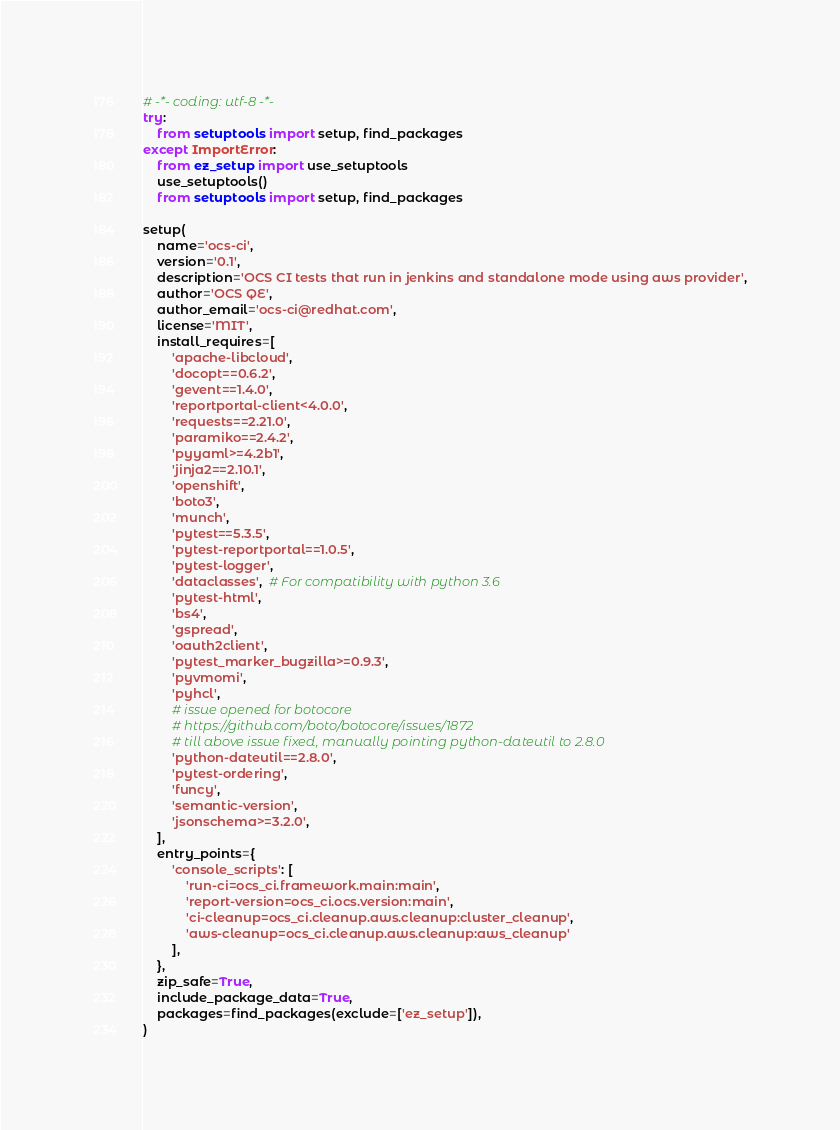Convert code to text. <code><loc_0><loc_0><loc_500><loc_500><_Python_># -*- coding: utf-8 -*-
try:
    from setuptools import setup, find_packages
except ImportError:
    from ez_setup import use_setuptools
    use_setuptools()
    from setuptools import setup, find_packages

setup(
    name='ocs-ci',
    version='0.1',
    description='OCS CI tests that run in jenkins and standalone mode using aws provider',
    author='OCS QE',
    author_email='ocs-ci@redhat.com',
    license='MIT',
    install_requires=[
        'apache-libcloud',
        'docopt==0.6.2',
        'gevent==1.4.0',
        'reportportal-client<4.0.0',
        'requests==2.21.0',
        'paramiko==2.4.2',
        'pyyaml>=4.2b1',
        'jinja2==2.10.1',
        'openshift',
        'boto3',
        'munch',
        'pytest==5.3.5',
        'pytest-reportportal==1.0.5',
        'pytest-logger',
        'dataclasses',  # For compatibility with python 3.6
        'pytest-html',
        'bs4',
        'gspread',
        'oauth2client',
        'pytest_marker_bugzilla>=0.9.3',
        'pyvmomi',
        'pyhcl',
        # issue opened for botocore
        # https://github.com/boto/botocore/issues/1872
        # till above issue fixed, manually pointing python-dateutil to 2.8.0
        'python-dateutil==2.8.0',
        'pytest-ordering',
        'funcy',
        'semantic-version',
        'jsonschema>=3.2.0',
    ],
    entry_points={
        'console_scripts': [
            'run-ci=ocs_ci.framework.main:main',
            'report-version=ocs_ci.ocs.version:main',
            'ci-cleanup=ocs_ci.cleanup.aws.cleanup:cluster_cleanup',
            'aws-cleanup=ocs_ci.cleanup.aws.cleanup:aws_cleanup'
        ],
    },
    zip_safe=True,
    include_package_data=True,
    packages=find_packages(exclude=['ez_setup']),
)
</code> 